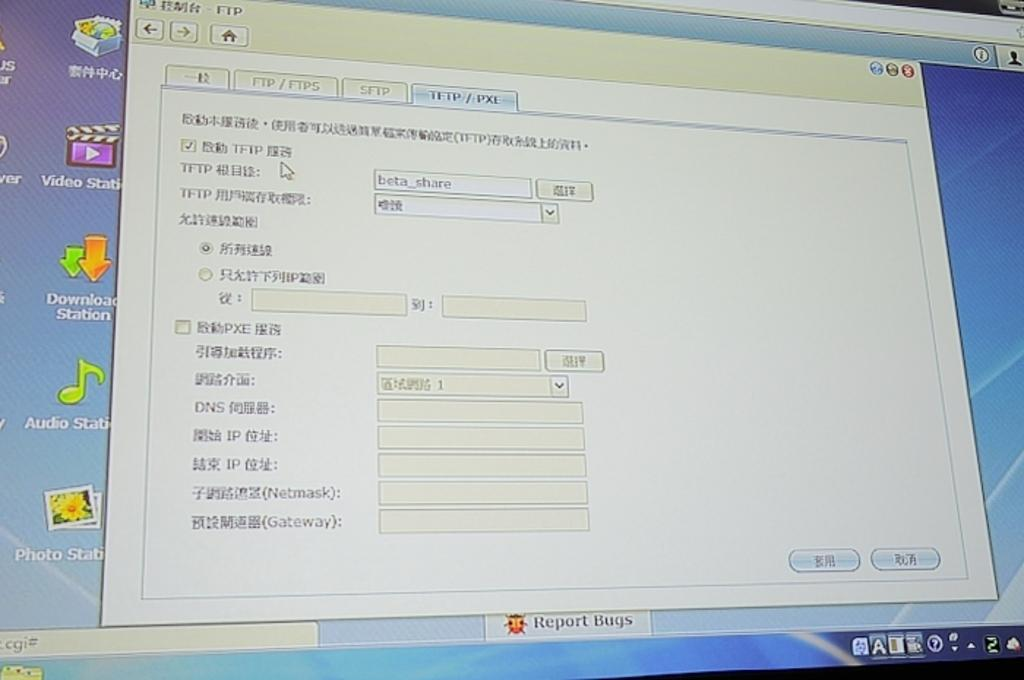What type of device is the image likely displayed on? The image appears to be a computer screen. Can you describe the setting in which the image was likely taken? The image was likely taken in a room. How many actors are visible in the image? There are no actors present in the image; it is a computer screen displaying an image or content. What type of furniture is visible in the image? There is no furniture visible in the image, as it is a computer screen displaying an image or content. 